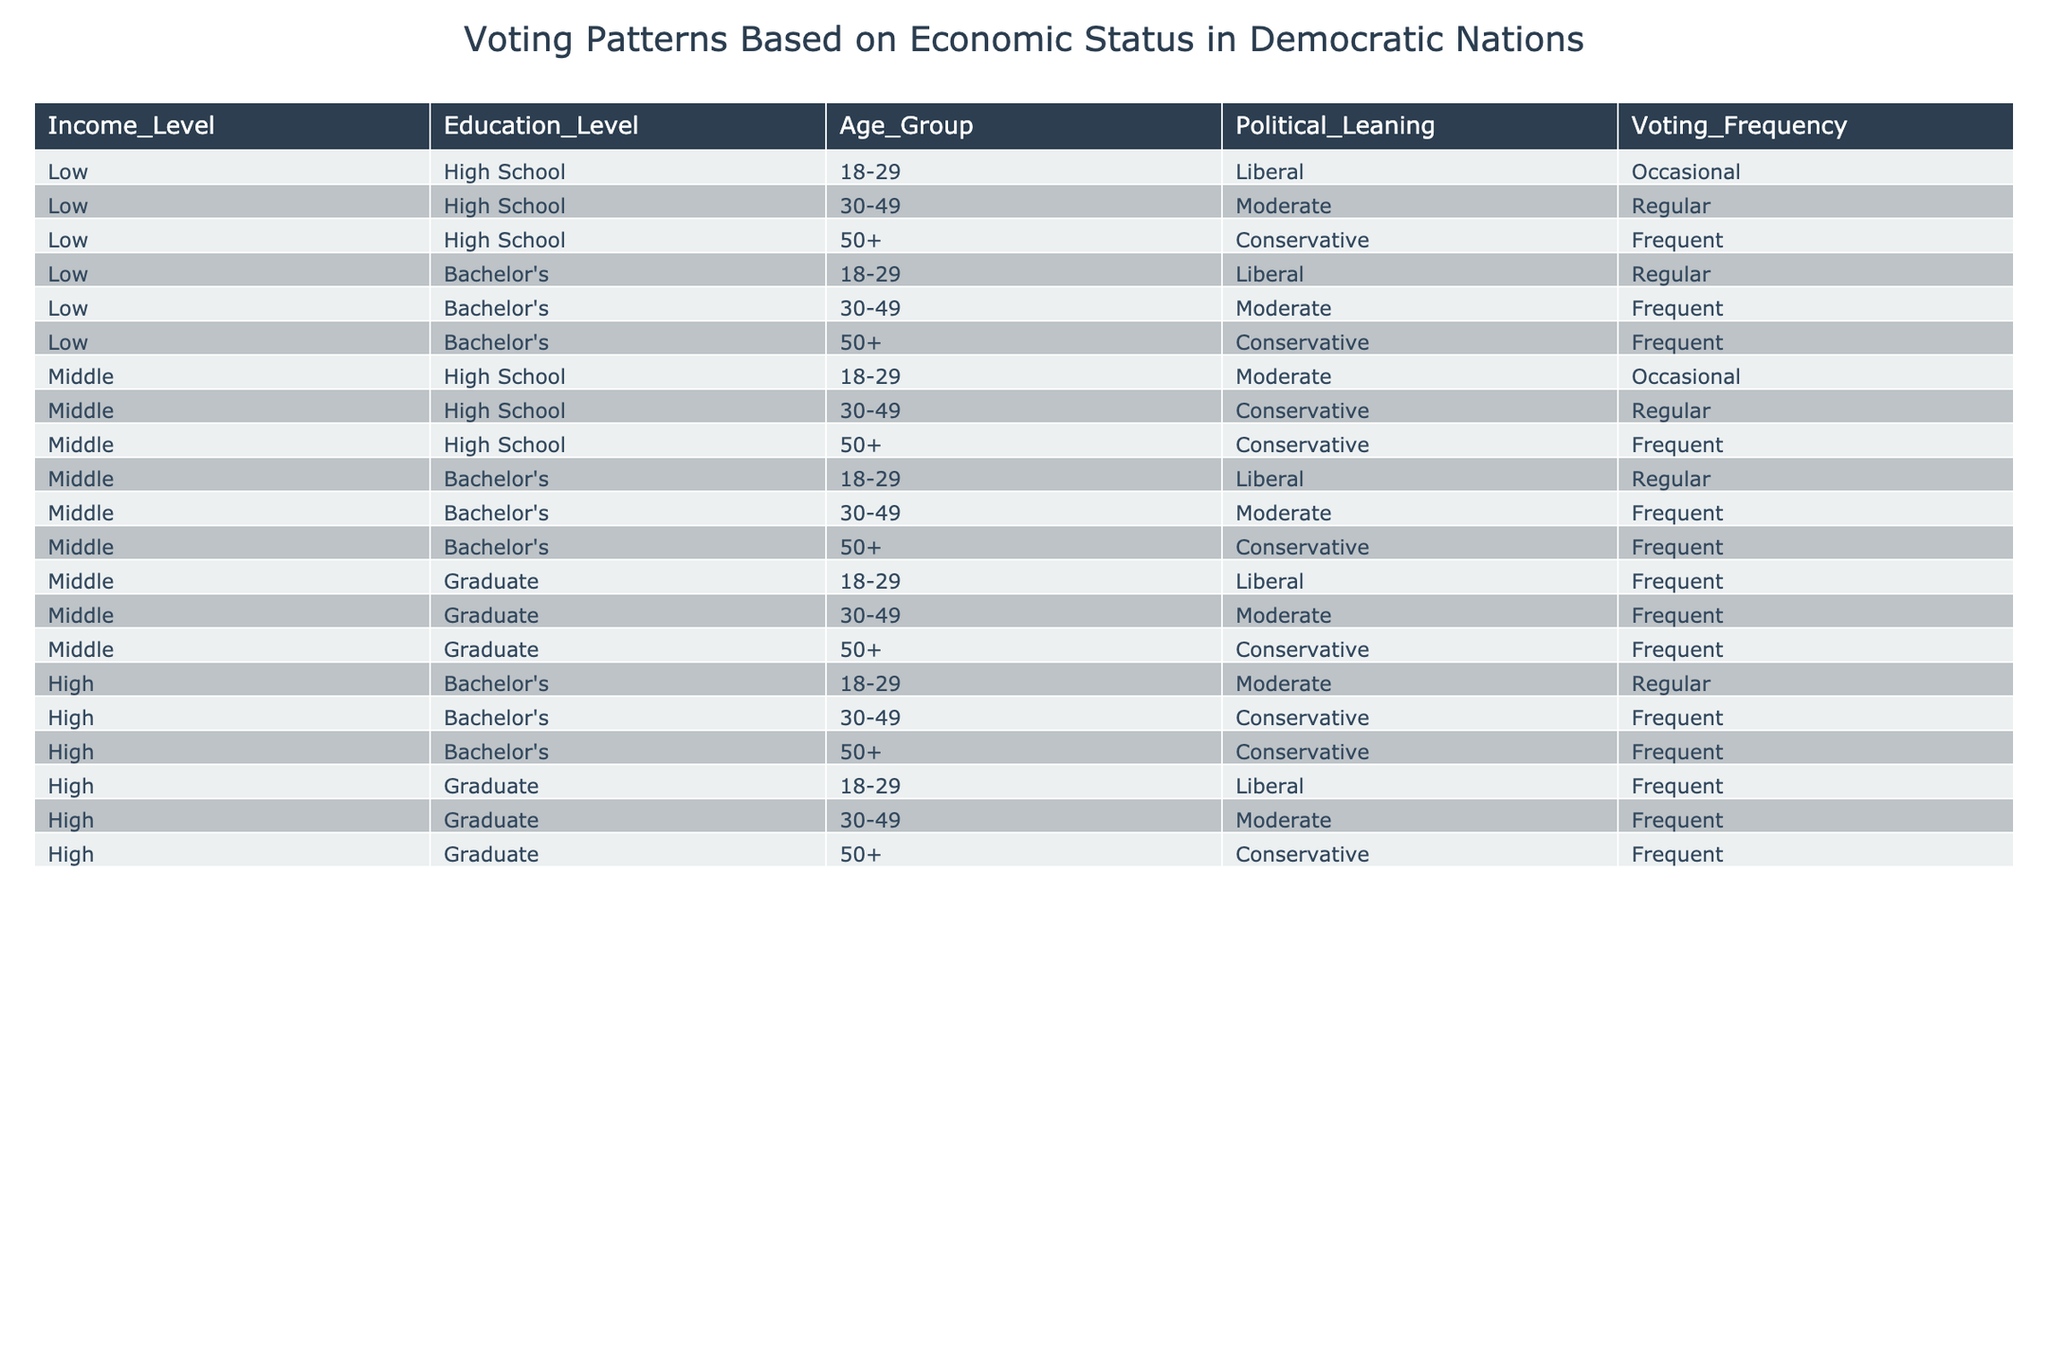What is the voting frequency of Low income individuals aged 50 and above? The table indicates that for individuals with Low income and aged 50+, the political leaning is Conservative and the voting frequency is Frequent.
Answer: Frequent How many different education levels are represented in the Middle income group? The Middle income group has individuals with three education levels: High School, Bachelor's, and Graduate. Therefore, there are three different education levels represented.
Answer: 3 Do individuals with a Bachelor's degree in the High income group lean more towards Conservative or Moderate? Within the High income group, individuals with a Bachelor's degree are only listed as Conservative for the age groups 30-49 and 50+. Thus, they do not lean towards Moderate at any age within this education level.
Answer: Conservative What is the total number of individuals with Regular voting frequency across all income levels? The table shows that Regular voting frequency occurs for the following cases: (Low, Bachelor's, 18-29), (Middle, Bachelor's, 18-29), (Middle, High School, 30-49), (High, Bachelor's, 18-29), (Middle, Graduate, 30-49), and (High, Graduate, 30-49). Counting these instances gives us 6 individuals with Regular voting frequency.
Answer: 6 Are there any Low income individuals with Frequent voting frequency? Yes, there are Low income individuals, specifically those aged 50+ with Conservative leaning who have a Frequent voting frequency (1 instance).
Answer: Yes How many individuals in the Middle income group are likely to vote Frequently? The Middle income group has individuals voting Frequently: (Middle, Bachelor's, 30-49), (Middle, Graduate, 18-29), (Middle, Graduate, 30-49), and (Middle, Graduate, 50+). This totals to 4 individuals in the Middle income group likely to vote Frequently.
Answer: 4 What is the relationship between Education Level and Voting Frequency for High income individuals? Analyzing the High income individuals, those with Bachelor's degrees have instances of Regular and Frequent voting frequency, while those with Graduate degrees primarily vote Frequently. This indicates that Higher Education correlates with more Frequent voting among High income individuals.
Answer: Higher Education correlates with more Frequent voting 